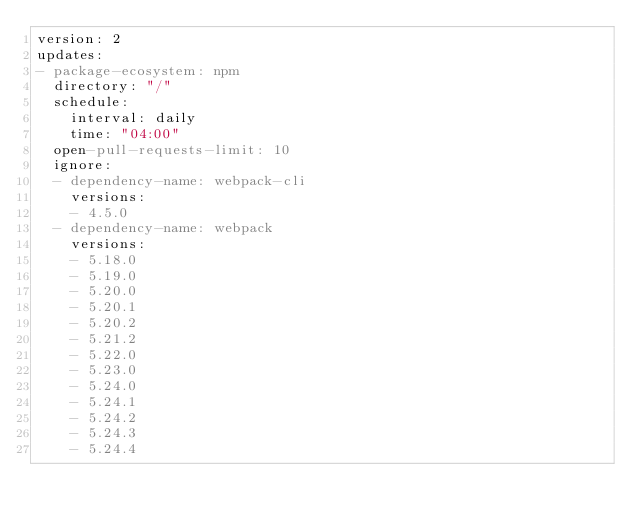<code> <loc_0><loc_0><loc_500><loc_500><_YAML_>version: 2
updates:
- package-ecosystem: npm
  directory: "/"
  schedule:
    interval: daily
    time: "04:00"
  open-pull-requests-limit: 10
  ignore:
  - dependency-name: webpack-cli
    versions:
    - 4.5.0
  - dependency-name: webpack
    versions:
    - 5.18.0
    - 5.19.0
    - 5.20.0
    - 5.20.1
    - 5.20.2
    - 5.21.2
    - 5.22.0
    - 5.23.0
    - 5.24.0
    - 5.24.1
    - 5.24.2
    - 5.24.3
    - 5.24.4
</code> 